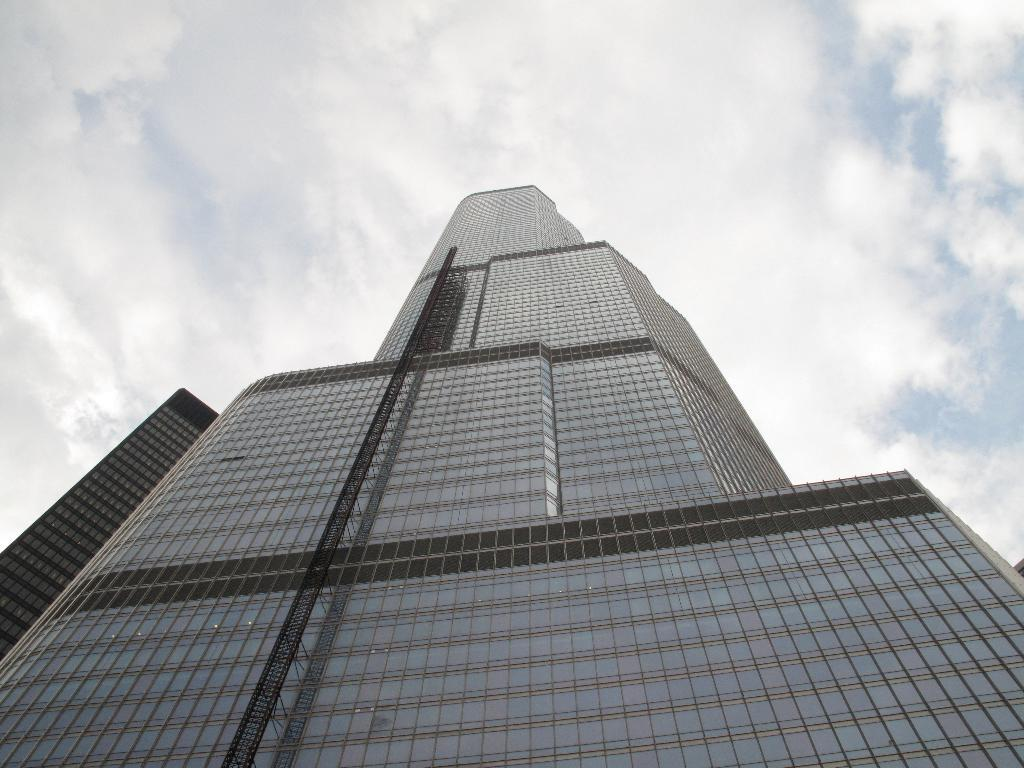What type of structure is present in the image? There is a building in the image. What can be seen in the background of the image? The sky is visible in the background of the image. What is the condition of the sky in the image? There are clouds in the sky. Who is the manager of the coal mine in the image? There is no coal mine or manager present in the image; it features a building and clouds in the sky. 